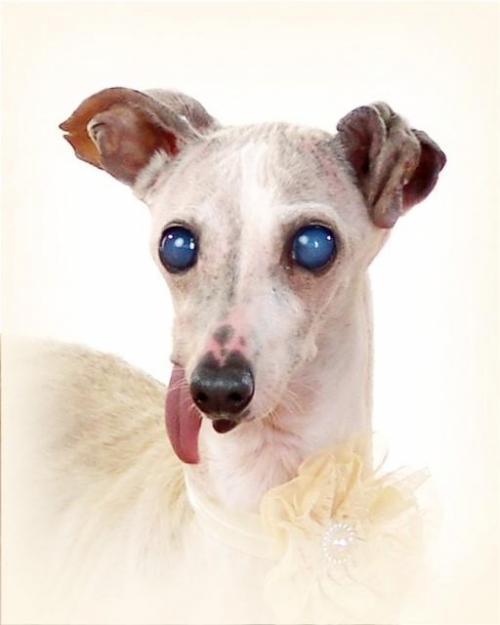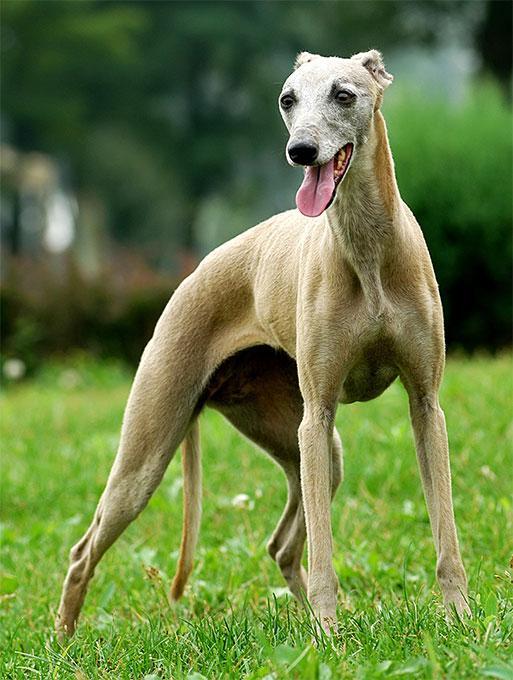The first image is the image on the left, the second image is the image on the right. Examine the images to the left and right. Is the description "At least one of the dogs is standing on all fours." accurate? Answer yes or no. Yes. The first image is the image on the left, the second image is the image on the right. Given the left and right images, does the statement "One image shows one non-spotted dog in a standing pose." hold true? Answer yes or no. Yes. 